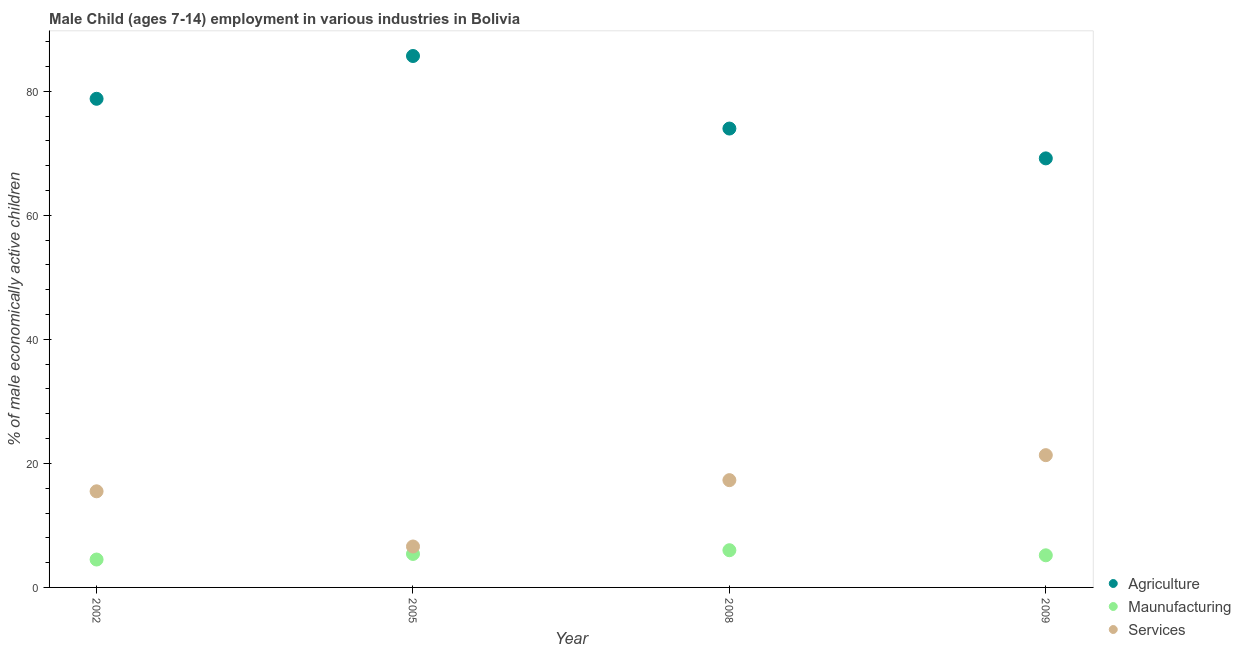What is the percentage of economically active children in services in 2009?
Provide a succinct answer. 21.33. Across all years, what is the maximum percentage of economically active children in agriculture?
Your response must be concise. 85.7. Across all years, what is the minimum percentage of economically active children in agriculture?
Offer a terse response. 69.19. In which year was the percentage of economically active children in manufacturing minimum?
Make the answer very short. 2002. What is the total percentage of economically active children in manufacturing in the graph?
Your response must be concise. 21.08. What is the difference between the percentage of economically active children in services in 2002 and that in 2009?
Make the answer very short. -5.83. What is the difference between the percentage of economically active children in manufacturing in 2002 and the percentage of economically active children in agriculture in 2005?
Your response must be concise. -81.2. What is the average percentage of economically active children in agriculture per year?
Keep it short and to the point. 76.92. In the year 2002, what is the difference between the percentage of economically active children in services and percentage of economically active children in agriculture?
Provide a short and direct response. -63.3. In how many years, is the percentage of economically active children in agriculture greater than 68 %?
Make the answer very short. 4. What is the ratio of the percentage of economically active children in agriculture in 2005 to that in 2008?
Your answer should be compact. 1.16. Is the percentage of economically active children in manufacturing in 2002 less than that in 2009?
Provide a succinct answer. Yes. Is the difference between the percentage of economically active children in manufacturing in 2002 and 2005 greater than the difference between the percentage of economically active children in services in 2002 and 2005?
Offer a very short reply. No. What is the difference between the highest and the second highest percentage of economically active children in services?
Your answer should be compact. 4.03. What is the difference between the highest and the lowest percentage of economically active children in services?
Provide a succinct answer. 14.73. In how many years, is the percentage of economically active children in manufacturing greater than the average percentage of economically active children in manufacturing taken over all years?
Provide a succinct answer. 2. Is the sum of the percentage of economically active children in agriculture in 2002 and 2008 greater than the maximum percentage of economically active children in manufacturing across all years?
Provide a succinct answer. Yes. Is the percentage of economically active children in services strictly greater than the percentage of economically active children in manufacturing over the years?
Provide a succinct answer. Yes. Is the percentage of economically active children in manufacturing strictly less than the percentage of economically active children in agriculture over the years?
Make the answer very short. Yes. How many years are there in the graph?
Make the answer very short. 4. What is the difference between two consecutive major ticks on the Y-axis?
Offer a very short reply. 20. Does the graph contain grids?
Give a very brief answer. No. Where does the legend appear in the graph?
Provide a short and direct response. Bottom right. How are the legend labels stacked?
Your answer should be very brief. Vertical. What is the title of the graph?
Provide a succinct answer. Male Child (ages 7-14) employment in various industries in Bolivia. Does "Private sector" appear as one of the legend labels in the graph?
Offer a very short reply. No. What is the label or title of the Y-axis?
Make the answer very short. % of male economically active children. What is the % of male economically active children of Agriculture in 2002?
Your answer should be very brief. 78.8. What is the % of male economically active children of Agriculture in 2005?
Offer a terse response. 85.7. What is the % of male economically active children of Agriculture in 2008?
Make the answer very short. 74. What is the % of male economically active children in Maunufacturing in 2008?
Give a very brief answer. 6. What is the % of male economically active children of Agriculture in 2009?
Your answer should be very brief. 69.19. What is the % of male economically active children in Maunufacturing in 2009?
Your answer should be compact. 5.18. What is the % of male economically active children of Services in 2009?
Your answer should be compact. 21.33. Across all years, what is the maximum % of male economically active children in Agriculture?
Make the answer very short. 85.7. Across all years, what is the maximum % of male economically active children in Services?
Offer a very short reply. 21.33. Across all years, what is the minimum % of male economically active children of Agriculture?
Keep it short and to the point. 69.19. What is the total % of male economically active children in Agriculture in the graph?
Provide a short and direct response. 307.69. What is the total % of male economically active children of Maunufacturing in the graph?
Your answer should be compact. 21.08. What is the total % of male economically active children in Services in the graph?
Provide a succinct answer. 60.73. What is the difference between the % of male economically active children in Services in 2002 and that in 2005?
Ensure brevity in your answer.  8.9. What is the difference between the % of male economically active children in Maunufacturing in 2002 and that in 2008?
Your answer should be compact. -1.5. What is the difference between the % of male economically active children in Services in 2002 and that in 2008?
Offer a very short reply. -1.8. What is the difference between the % of male economically active children in Agriculture in 2002 and that in 2009?
Offer a very short reply. 9.61. What is the difference between the % of male economically active children in Maunufacturing in 2002 and that in 2009?
Give a very brief answer. -0.68. What is the difference between the % of male economically active children of Services in 2002 and that in 2009?
Provide a short and direct response. -5.83. What is the difference between the % of male economically active children of Maunufacturing in 2005 and that in 2008?
Offer a very short reply. -0.6. What is the difference between the % of male economically active children in Services in 2005 and that in 2008?
Provide a short and direct response. -10.7. What is the difference between the % of male economically active children of Agriculture in 2005 and that in 2009?
Ensure brevity in your answer.  16.51. What is the difference between the % of male economically active children of Maunufacturing in 2005 and that in 2009?
Provide a short and direct response. 0.22. What is the difference between the % of male economically active children of Services in 2005 and that in 2009?
Offer a very short reply. -14.73. What is the difference between the % of male economically active children of Agriculture in 2008 and that in 2009?
Offer a very short reply. 4.81. What is the difference between the % of male economically active children of Maunufacturing in 2008 and that in 2009?
Give a very brief answer. 0.82. What is the difference between the % of male economically active children of Services in 2008 and that in 2009?
Give a very brief answer. -4.03. What is the difference between the % of male economically active children of Agriculture in 2002 and the % of male economically active children of Maunufacturing in 2005?
Give a very brief answer. 73.4. What is the difference between the % of male economically active children of Agriculture in 2002 and the % of male economically active children of Services in 2005?
Make the answer very short. 72.2. What is the difference between the % of male economically active children in Maunufacturing in 2002 and the % of male economically active children in Services in 2005?
Keep it short and to the point. -2.1. What is the difference between the % of male economically active children in Agriculture in 2002 and the % of male economically active children in Maunufacturing in 2008?
Offer a terse response. 72.8. What is the difference between the % of male economically active children of Agriculture in 2002 and the % of male economically active children of Services in 2008?
Offer a terse response. 61.5. What is the difference between the % of male economically active children in Agriculture in 2002 and the % of male economically active children in Maunufacturing in 2009?
Keep it short and to the point. 73.62. What is the difference between the % of male economically active children in Agriculture in 2002 and the % of male economically active children in Services in 2009?
Ensure brevity in your answer.  57.47. What is the difference between the % of male economically active children of Maunufacturing in 2002 and the % of male economically active children of Services in 2009?
Provide a short and direct response. -16.83. What is the difference between the % of male economically active children in Agriculture in 2005 and the % of male economically active children in Maunufacturing in 2008?
Make the answer very short. 79.7. What is the difference between the % of male economically active children in Agriculture in 2005 and the % of male economically active children in Services in 2008?
Make the answer very short. 68.4. What is the difference between the % of male economically active children in Maunufacturing in 2005 and the % of male economically active children in Services in 2008?
Your response must be concise. -11.9. What is the difference between the % of male economically active children of Agriculture in 2005 and the % of male economically active children of Maunufacturing in 2009?
Keep it short and to the point. 80.52. What is the difference between the % of male economically active children of Agriculture in 2005 and the % of male economically active children of Services in 2009?
Give a very brief answer. 64.37. What is the difference between the % of male economically active children of Maunufacturing in 2005 and the % of male economically active children of Services in 2009?
Ensure brevity in your answer.  -15.93. What is the difference between the % of male economically active children in Agriculture in 2008 and the % of male economically active children in Maunufacturing in 2009?
Your answer should be very brief. 68.82. What is the difference between the % of male economically active children of Agriculture in 2008 and the % of male economically active children of Services in 2009?
Provide a short and direct response. 52.67. What is the difference between the % of male economically active children in Maunufacturing in 2008 and the % of male economically active children in Services in 2009?
Your answer should be compact. -15.33. What is the average % of male economically active children of Agriculture per year?
Provide a short and direct response. 76.92. What is the average % of male economically active children of Maunufacturing per year?
Your answer should be compact. 5.27. What is the average % of male economically active children of Services per year?
Make the answer very short. 15.18. In the year 2002, what is the difference between the % of male economically active children of Agriculture and % of male economically active children of Maunufacturing?
Provide a succinct answer. 74.3. In the year 2002, what is the difference between the % of male economically active children in Agriculture and % of male economically active children in Services?
Make the answer very short. 63.3. In the year 2005, what is the difference between the % of male economically active children of Agriculture and % of male economically active children of Maunufacturing?
Keep it short and to the point. 80.3. In the year 2005, what is the difference between the % of male economically active children of Agriculture and % of male economically active children of Services?
Your response must be concise. 79.1. In the year 2008, what is the difference between the % of male economically active children in Agriculture and % of male economically active children in Services?
Your response must be concise. 56.7. In the year 2009, what is the difference between the % of male economically active children in Agriculture and % of male economically active children in Maunufacturing?
Give a very brief answer. 64.01. In the year 2009, what is the difference between the % of male economically active children of Agriculture and % of male economically active children of Services?
Your response must be concise. 47.86. In the year 2009, what is the difference between the % of male economically active children in Maunufacturing and % of male economically active children in Services?
Keep it short and to the point. -16.15. What is the ratio of the % of male economically active children of Agriculture in 2002 to that in 2005?
Your answer should be compact. 0.92. What is the ratio of the % of male economically active children of Maunufacturing in 2002 to that in 2005?
Your response must be concise. 0.83. What is the ratio of the % of male economically active children in Services in 2002 to that in 2005?
Your answer should be compact. 2.35. What is the ratio of the % of male economically active children of Agriculture in 2002 to that in 2008?
Provide a succinct answer. 1.06. What is the ratio of the % of male economically active children of Maunufacturing in 2002 to that in 2008?
Keep it short and to the point. 0.75. What is the ratio of the % of male economically active children of Services in 2002 to that in 2008?
Provide a succinct answer. 0.9. What is the ratio of the % of male economically active children of Agriculture in 2002 to that in 2009?
Your answer should be very brief. 1.14. What is the ratio of the % of male economically active children of Maunufacturing in 2002 to that in 2009?
Offer a terse response. 0.87. What is the ratio of the % of male economically active children of Services in 2002 to that in 2009?
Keep it short and to the point. 0.73. What is the ratio of the % of male economically active children in Agriculture in 2005 to that in 2008?
Your answer should be very brief. 1.16. What is the ratio of the % of male economically active children of Maunufacturing in 2005 to that in 2008?
Make the answer very short. 0.9. What is the ratio of the % of male economically active children of Services in 2005 to that in 2008?
Your response must be concise. 0.38. What is the ratio of the % of male economically active children in Agriculture in 2005 to that in 2009?
Offer a very short reply. 1.24. What is the ratio of the % of male economically active children in Maunufacturing in 2005 to that in 2009?
Ensure brevity in your answer.  1.04. What is the ratio of the % of male economically active children in Services in 2005 to that in 2009?
Offer a terse response. 0.31. What is the ratio of the % of male economically active children in Agriculture in 2008 to that in 2009?
Offer a very short reply. 1.07. What is the ratio of the % of male economically active children in Maunufacturing in 2008 to that in 2009?
Offer a very short reply. 1.16. What is the ratio of the % of male economically active children in Services in 2008 to that in 2009?
Give a very brief answer. 0.81. What is the difference between the highest and the second highest % of male economically active children in Agriculture?
Your response must be concise. 6.9. What is the difference between the highest and the second highest % of male economically active children in Maunufacturing?
Keep it short and to the point. 0.6. What is the difference between the highest and the second highest % of male economically active children of Services?
Your answer should be very brief. 4.03. What is the difference between the highest and the lowest % of male economically active children in Agriculture?
Your answer should be very brief. 16.51. What is the difference between the highest and the lowest % of male economically active children in Maunufacturing?
Offer a terse response. 1.5. What is the difference between the highest and the lowest % of male economically active children of Services?
Provide a succinct answer. 14.73. 